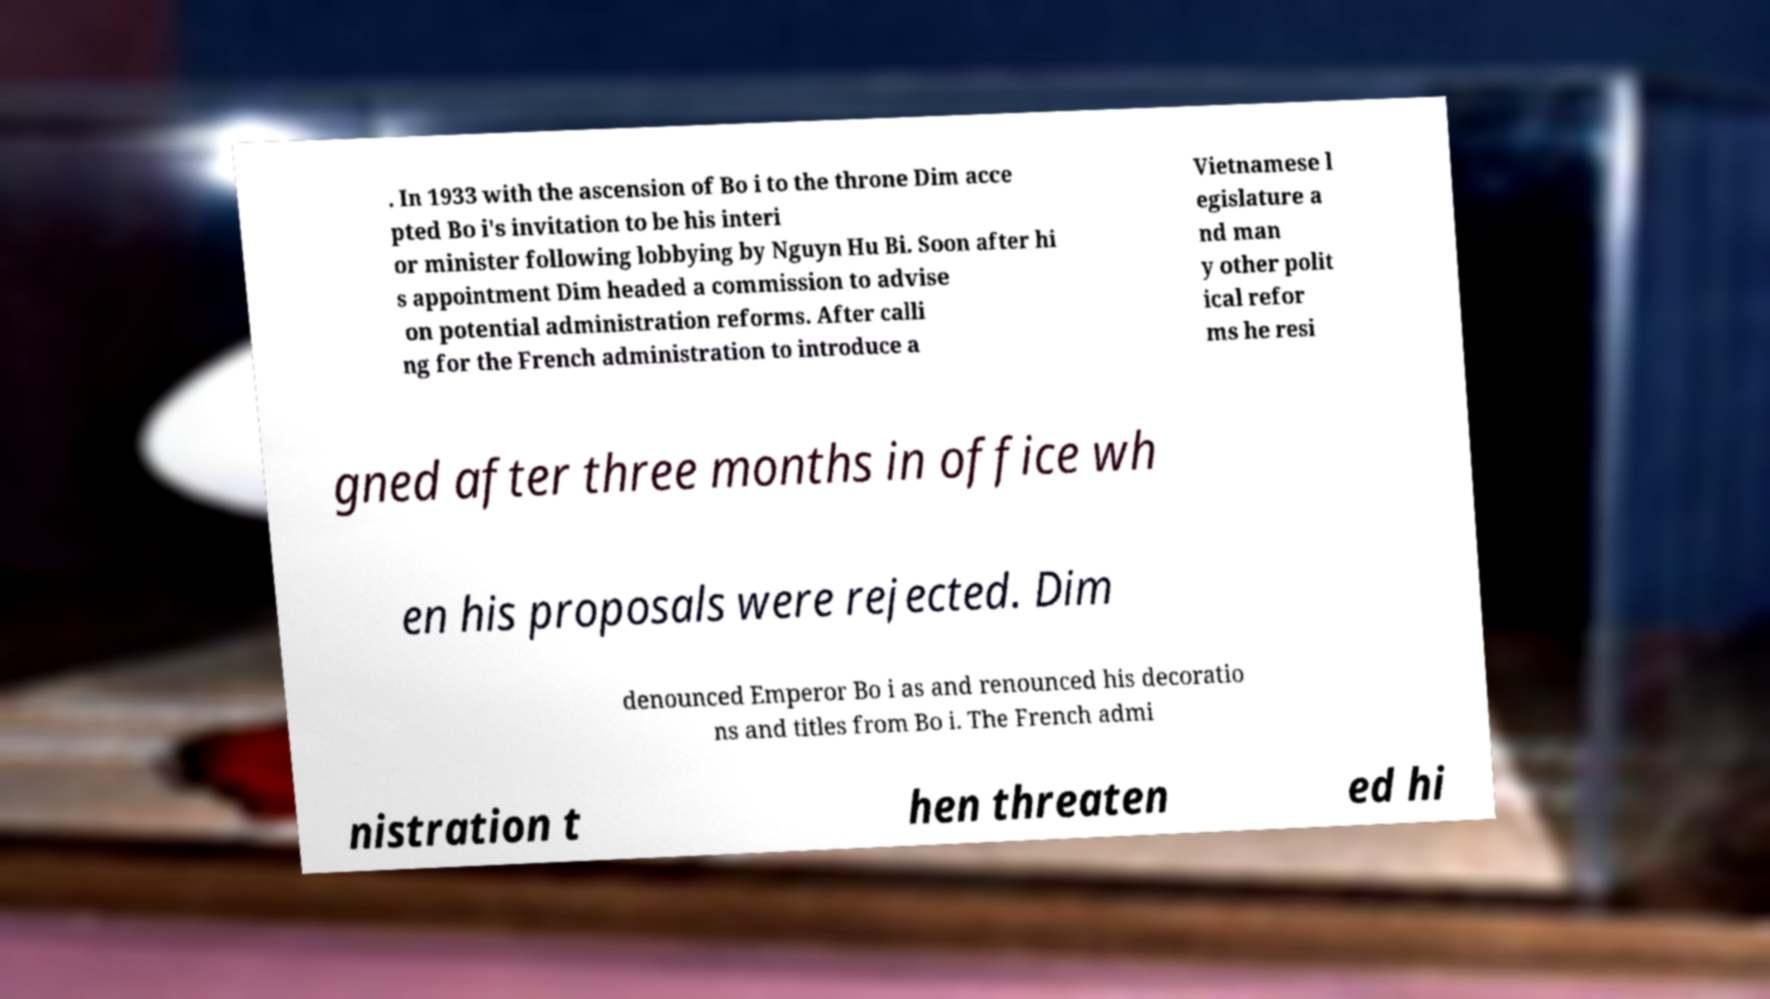Please read and relay the text visible in this image. What does it say? . In 1933 with the ascension of Bo i to the throne Dim acce pted Bo i's invitation to be his interi or minister following lobbying by Nguyn Hu Bi. Soon after hi s appointment Dim headed a commission to advise on potential administration reforms. After calli ng for the French administration to introduce a Vietnamese l egislature a nd man y other polit ical refor ms he resi gned after three months in office wh en his proposals were rejected. Dim denounced Emperor Bo i as and renounced his decoratio ns and titles from Bo i. The French admi nistration t hen threaten ed hi 